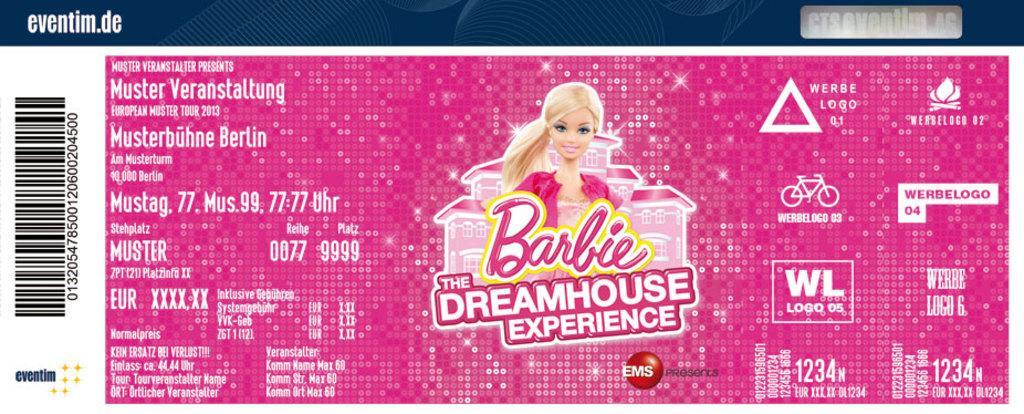Describe this image in one or two sentences. In the middle of the picture, we see a barbie doll. Behind her, we see a pink color house. In the background, it is in pink color. We see some text written. On the left side, we see the barcode. This picture might be a sticker. 